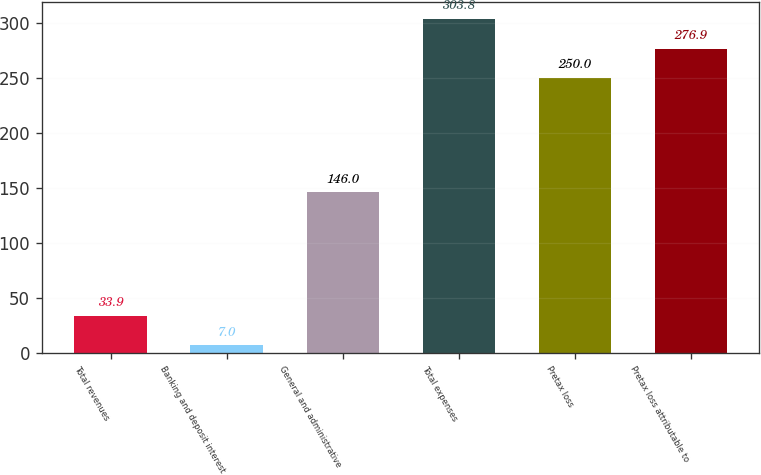Convert chart to OTSL. <chart><loc_0><loc_0><loc_500><loc_500><bar_chart><fcel>Total revenues<fcel>Banking and deposit interest<fcel>General and administrative<fcel>Total expenses<fcel>Pretax loss<fcel>Pretax loss attributable to<nl><fcel>33.9<fcel>7<fcel>146<fcel>303.8<fcel>250<fcel>276.9<nl></chart> 